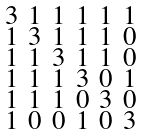<formula> <loc_0><loc_0><loc_500><loc_500>\begin{smallmatrix} 3 & 1 & 1 & 1 & 1 & 1 \\ 1 & 3 & 1 & 1 & 1 & 0 \\ 1 & 1 & 3 & 1 & 1 & 0 \\ 1 & 1 & 1 & 3 & 0 & 1 \\ 1 & 1 & 1 & 0 & 3 & 0 \\ 1 & 0 & 0 & 1 & 0 & 3 \end{smallmatrix}</formula> 